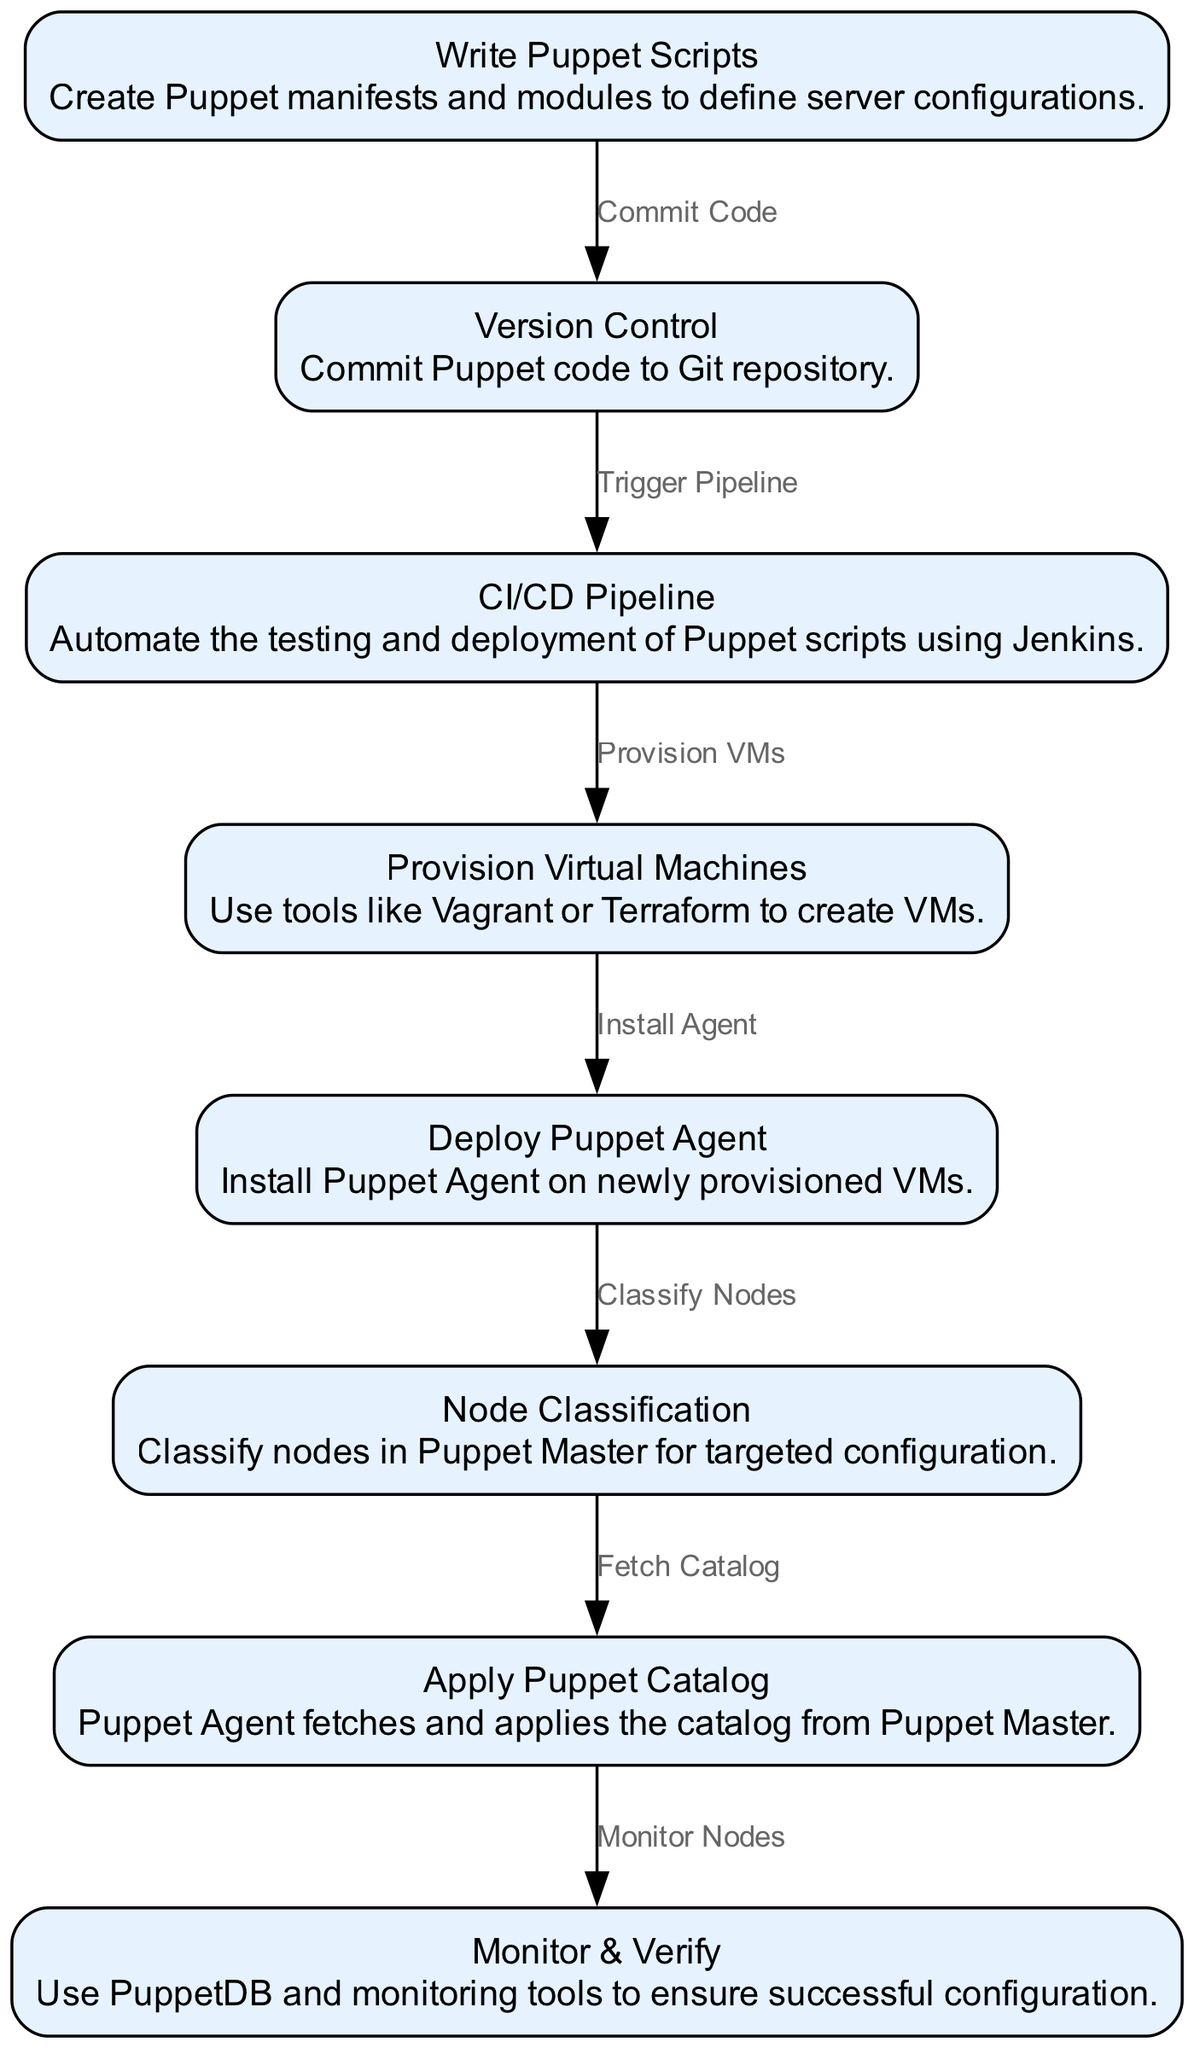What is the first step in the automated server provisioning workflow? The diagram shows that the first step is "Write Puppet Scripts," where Puppet manifests and modules are created to define server configurations.
Answer: Write Puppet Scripts How many nodes are present in the diagram? By counting the nodes listed in the data, there are eight distinct nodes, each representing a step in the provisioning workflow.
Answer: 8 What is the label of the node that follows "Version Control"? The diagram indicates the next node after "Version Control" is "CI/CD Pipeline," which automates testing and deployment of Puppet scripts.
Answer: CI/CD Pipeline Which tool is used to provision virtual machines in this workflow? The workflow includes a step labeled "Provision Virtual Machines" where tools like Vagrant or Terraform are used for VM creation.
Answer: Vagrant or Terraform Describe the relationship between "Deploy Puppet Agent" and "Node Classification." In the diagram, "Deploy Puppet Agent" leads to "Node Classification," indicating that after the Puppet Agent is installed on the VMs, the next step is to classify these nodes in Puppet Master.
Answer: Install Agent → Classify Nodes What happens after the Puppet Agent applies the catalog? The diagram shows that after the Puppet Agent applies the catalog, the next step is "Monitor & Verify," where PuppetDB and monitoring tools ensure successful configuration.
Answer: Monitor & Verify Which node is the last step in the automated server provisioning workflow? The last node in the workflow is labeled "Monitor & Verify," which concludes the end-to-end process.
Answer: Monitor & Verify What action is triggered after committing Puppet code to a Git repository? Following the commitment of Puppet code, the diagram indicates that it triggers the CI/CD pipeline for further automation in the deployment process.
Answer: Trigger Pipeline 